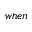<formula> <loc_0><loc_0><loc_500><loc_500>w h e n</formula> 